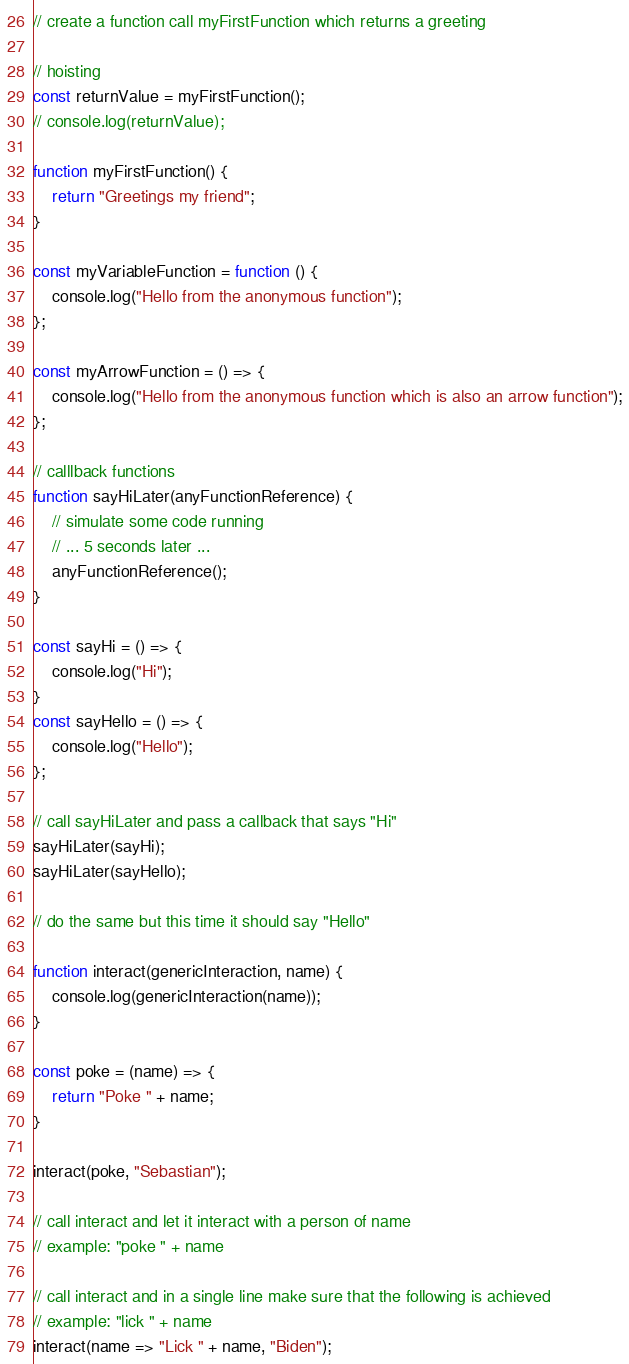Convert code to text. <code><loc_0><loc_0><loc_500><loc_500><_JavaScript_>// create a function call myFirstFunction which returns a greeting

// hoisting
const returnValue = myFirstFunction();
// console.log(returnValue);

function myFirstFunction() {
    return "Greetings my friend";
}

const myVariableFunction = function () {
    console.log("Hello from the anonymous function");
};

const myArrowFunction = () => {
    console.log("Hello from the anonymous function which is also an arrow function");
};

// calllback functions
function sayHiLater(anyFunctionReference) {
    // simulate some code running
    // ... 5 seconds later ... 
    anyFunctionReference();
}

const sayHi = () => {
    console.log("Hi");
}
const sayHello = () => {
    console.log("Hello");
};

// call sayHiLater and pass a callback that says "Hi"
sayHiLater(sayHi);
sayHiLater(sayHello);

// do the same but this time it should say "Hello"

function interact(genericInteraction, name) {
    console.log(genericInteraction(name));
}

const poke = (name) => {
    return "Poke " + name;
}

interact(poke, "Sebastian");

// call interact and let it interact with a person of name
// example: "poke " + name

// call interact and in a single line make sure that the following is achieved
// example: "lick " + name
interact(name => "Lick " + name, "Biden");
</code> 